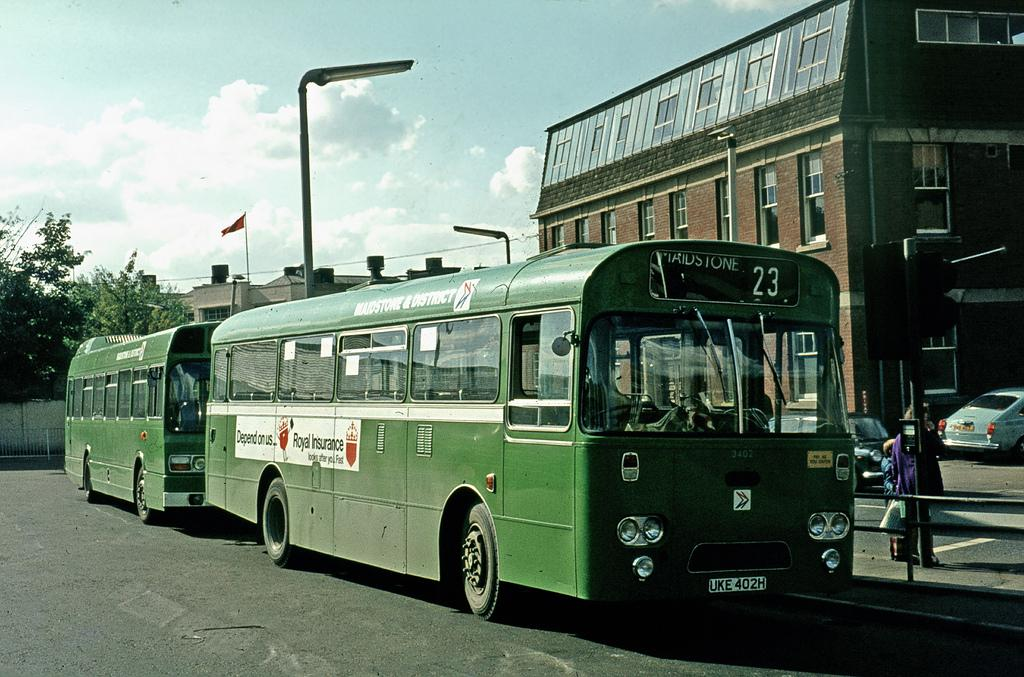Question: what color is this bus?
Choices:
A. Blue.
B. Orange.
C. White.
D. Green.
Answer with the letter. Answer: D Question: how many buses are there?
Choices:
A. Three.
B. Two.
C. One.
D. Four.
Answer with the letter. Answer: B Question: where are these buses?
Choices:
A. At the bus stop.
B. On the road.
C. At the gas station.
D. At the park.
Answer with the letter. Answer: A Question: what are retro style?
Choices:
A. Clothes.
B. The buses.
C. Shoes.
D. Hairstyle.
Answer with the letter. Answer: B Question: what are behind the buses?
Choices:
A. Exhaust fumes.
B. Children.
C. Trees.
D. Visible vehicles.
Answer with the letter. Answer: D Question: what style are these buses?
Choices:
A. School.
B. Retro.
C. Travel coach.
D. Tour.
Answer with the letter. Answer: B Question: where is the car located?
Choices:
A. In the parking lot.
B. By other cars.
C. To the right of the buses.
D. Next to the sidewalk.
Answer with the letter. Answer: C Question: what's in the background?
Choices:
A. A building.
B. An tree.
C. A car.
D. A plant.
Answer with the letter. Answer: A Question: who is wearing a coat?
Choices:
A. A woman.
B. A man.
C. A boy.
D. A girl.
Answer with the letter. Answer: A Question: what color is the coat?
Choices:
A. Green.
B. Purple.
C. Black.
D. Yellow.
Answer with the letter. Answer: B Question: what state are the windows in?
Choices:
A. Closed.
B. Open.
C. Half way opened.
D. Broken.
Answer with the letter. Answer: A Question: what is green?
Choices:
A. The car.
B. The bike.
C. The motorcycle.
D. The bus.
Answer with the letter. Answer: D Question: what's parked near the building?
Choices:
A. A bike.
B. A bus.
C. A truck.
D. A car.
Answer with the letter. Answer: D Question: where is the destination information displayed?
Choices:
A. Inside.
B. On the side.
C. On the back.
D. On the front.
Answer with the letter. Answer: D Question: what has headlights?
Choices:
A. The car.
B. The motorcycle.
C. The bus.
D. The truck.
Answer with the letter. Answer: C Question: where are the headlights?
Choices:
A. On the car.
B. On the truck.
C. On the van.
D. On the bus.
Answer with the letter. Answer: D Question: where is a flag?
Choices:
A. In a case.
B. On a pole.
C. On a wall.
D. On a home.
Answer with the letter. Answer: B Question: where is the pole located?
Choices:
A. In the distance.
B. In the foreground.
C. In the grass.
D. By a school.
Answer with the letter. Answer: A Question: what is the building made of?
Choices:
A. Bricks.
B. Concrete.
C. Wood.
D. Siding.
Answer with the letter. Answer: A Question: what is the sky's condition?
Choices:
A. Cloudy.
B. Sunny.
C. Hazy.
D. Clear.
Answer with the letter. Answer: D Question: what is the time, roughly?
Choices:
A. Morning.
B. Evening.
C. Daytime.
D. Afternoon.
Answer with the letter. Answer: C Question: where are the tires?
Choices:
A. On the bike.
B. On the motorcycle.
C. On the bus.
D. On the car.
Answer with the letter. Answer: C Question: who is holding a bag?
Choices:
A. The woman.
B. The employee.
C. The child.
D. The man.
Answer with the letter. Answer: A Question: where do they advertise?
Choices:
A. On billboards.
B. On cabs.
C. On the bus.
D. On signs.
Answer with the letter. Answer: C Question: how many visible vehicles are there?
Choices:
A. Three.
B. One.
C. Four.
D. Two.
Answer with the letter. Answer: D Question: what classification would the buses belong to?
Choices:
A. Travel.
B. Tour.
C. School.
D. Vintage.
Answer with the letter. Answer: D Question: what do the photographs do?
Choices:
A. Save memories.
B. Represent vintage buses.
C. Decorate.
D. Hang on the wall.
Answer with the letter. Answer: B Question: what is behind the second bus?
Choices:
A. Yellow trees.
B. Green trees.
C. Brown trees.
D. Cacti.
Answer with the letter. Answer: B Question: what color is this person wearing?
Choices:
A. Purple.
B. Blue.
C. Orange.
D. Red.
Answer with the letter. Answer: A Question: how are people going?
Choices:
A. By train.
B. By plane.
C. By bus.
D. By car.
Answer with the letter. Answer: C Question: what kind of transportation is this?
Choices:
A. Car.
B. Truck.
C. Bus.
D. Plane.
Answer with the letter. Answer: C 